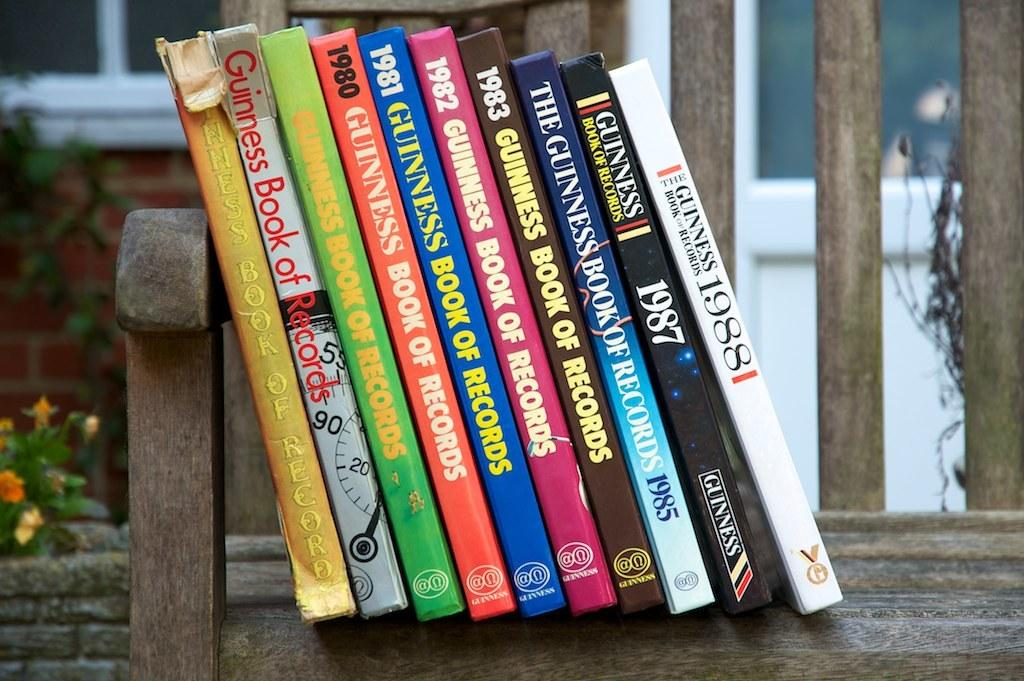<image>
Summarize the visual content of the image. A collection of previous volumes of Guinness World Records sets on a wooden surface. 